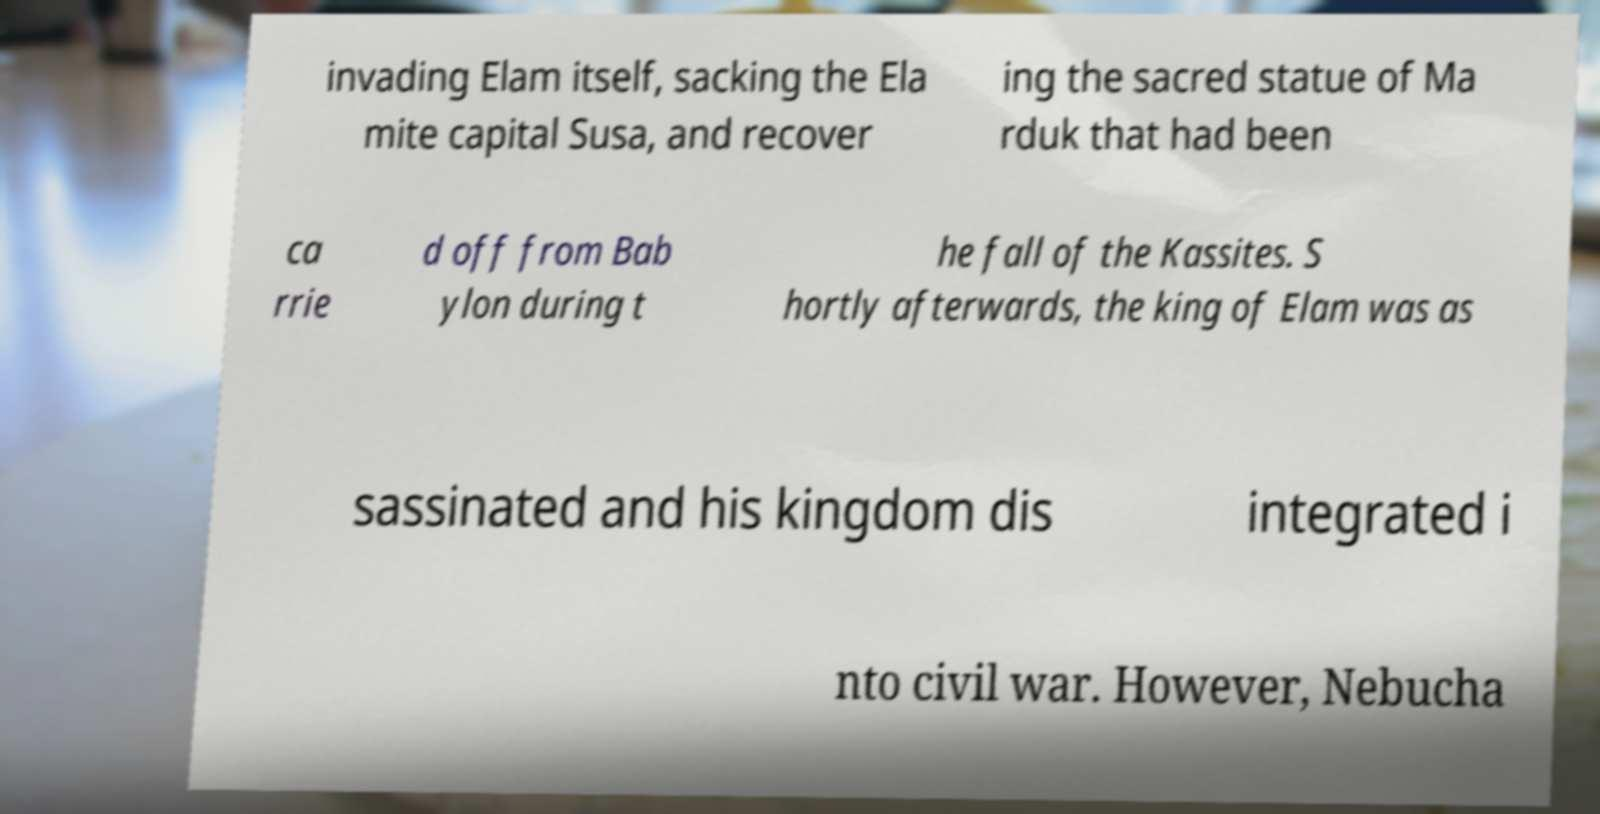Please read and relay the text visible in this image. What does it say? invading Elam itself, sacking the Ela mite capital Susa, and recover ing the sacred statue of Ma rduk that had been ca rrie d off from Bab ylon during t he fall of the Kassites. S hortly afterwards, the king of Elam was as sassinated and his kingdom dis integrated i nto civil war. However, Nebucha 